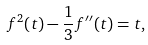Convert formula to latex. <formula><loc_0><loc_0><loc_500><loc_500>f ^ { 2 } ( t ) - { \frac { 1 } { 3 } } f ^ { \prime \prime } ( t ) = t ,</formula> 